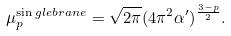<formula> <loc_0><loc_0><loc_500><loc_500>\mu _ { p } ^ { \sin g l e b r a n e } = \sqrt { 2 \pi } ( 4 \pi ^ { 2 } \alpha ^ { \prime } ) ^ { \frac { 3 - p } { 2 } } .</formula> 